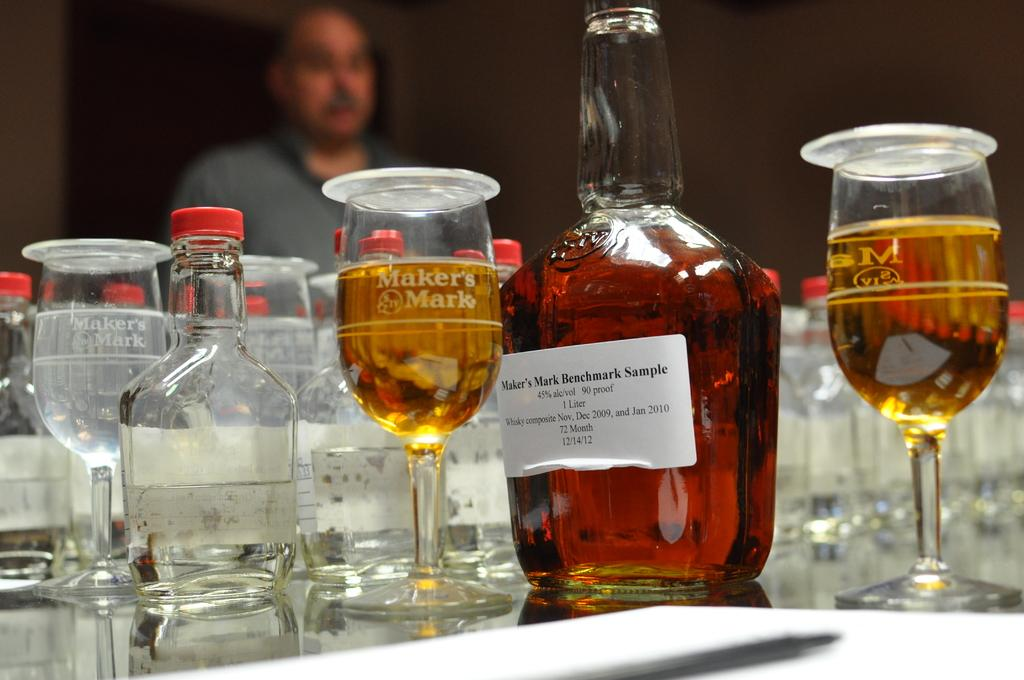What is located in the foreground of the picture? There is a table in the foreground of the picture. What is on the table? There is a whiskey bottle and many glasses on the table. Can you describe the person in the background of the image? There is a person standing in the background of the image. What type of wax is being used to create the space-like atmosphere in the image? There is no wax or space-like atmosphere present in the image; it features a table with a whiskey bottle and glasses, and a person standing in the background. 